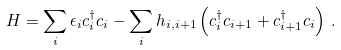<formula> <loc_0><loc_0><loc_500><loc_500>H = \sum _ { i } \epsilon _ { i } c ^ { \dagger } _ { i } c _ { i } - \sum _ { i } h _ { i , i + 1 } \left ( c ^ { \dagger } _ { i } c _ { i + 1 } + c ^ { \dagger } _ { i + 1 } c _ { i } \right ) \, .</formula> 